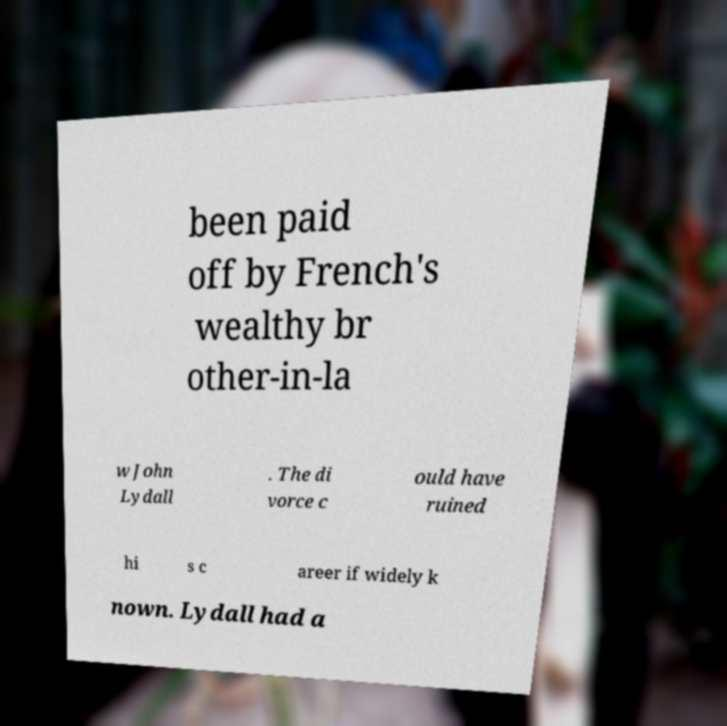Could you extract and type out the text from this image? been paid off by French's wealthy br other-in-la w John Lydall . The di vorce c ould have ruined hi s c areer if widely k nown. Lydall had a 